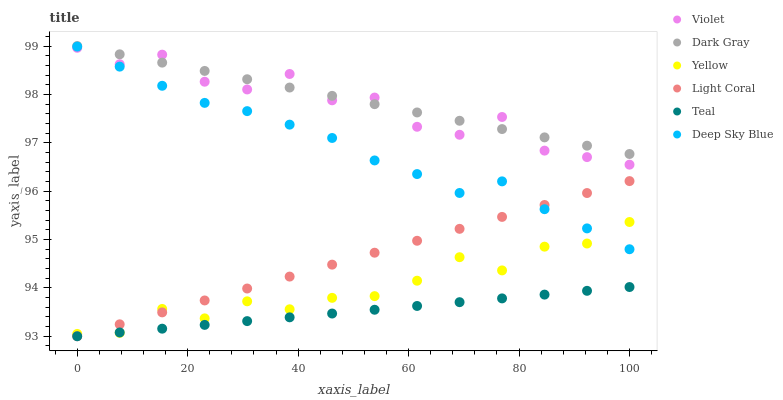Does Teal have the minimum area under the curve?
Answer yes or no. Yes. Does Dark Gray have the maximum area under the curve?
Answer yes or no. Yes. Does Yellow have the minimum area under the curve?
Answer yes or no. No. Does Yellow have the maximum area under the curve?
Answer yes or no. No. Is Light Coral the smoothest?
Answer yes or no. Yes. Is Violet the roughest?
Answer yes or no. Yes. Is Teal the smoothest?
Answer yes or no. No. Is Teal the roughest?
Answer yes or no. No. Does Light Coral have the lowest value?
Answer yes or no. Yes. Does Yellow have the lowest value?
Answer yes or no. No. Does Dark Gray have the highest value?
Answer yes or no. Yes. Does Yellow have the highest value?
Answer yes or no. No. Is Teal less than Dark Gray?
Answer yes or no. Yes. Is Dark Gray greater than Yellow?
Answer yes or no. Yes. Does Violet intersect Dark Gray?
Answer yes or no. Yes. Is Violet less than Dark Gray?
Answer yes or no. No. Is Violet greater than Dark Gray?
Answer yes or no. No. Does Teal intersect Dark Gray?
Answer yes or no. No. 